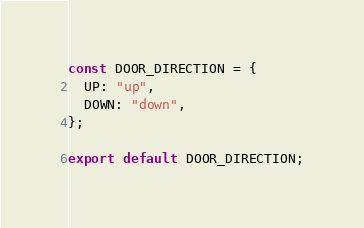Convert code to text. <code><loc_0><loc_0><loc_500><loc_500><_JavaScript_>const DOOR_DIRECTION = {
  UP: "up",
  DOWN: "down",
};

export default DOOR_DIRECTION;
</code> 